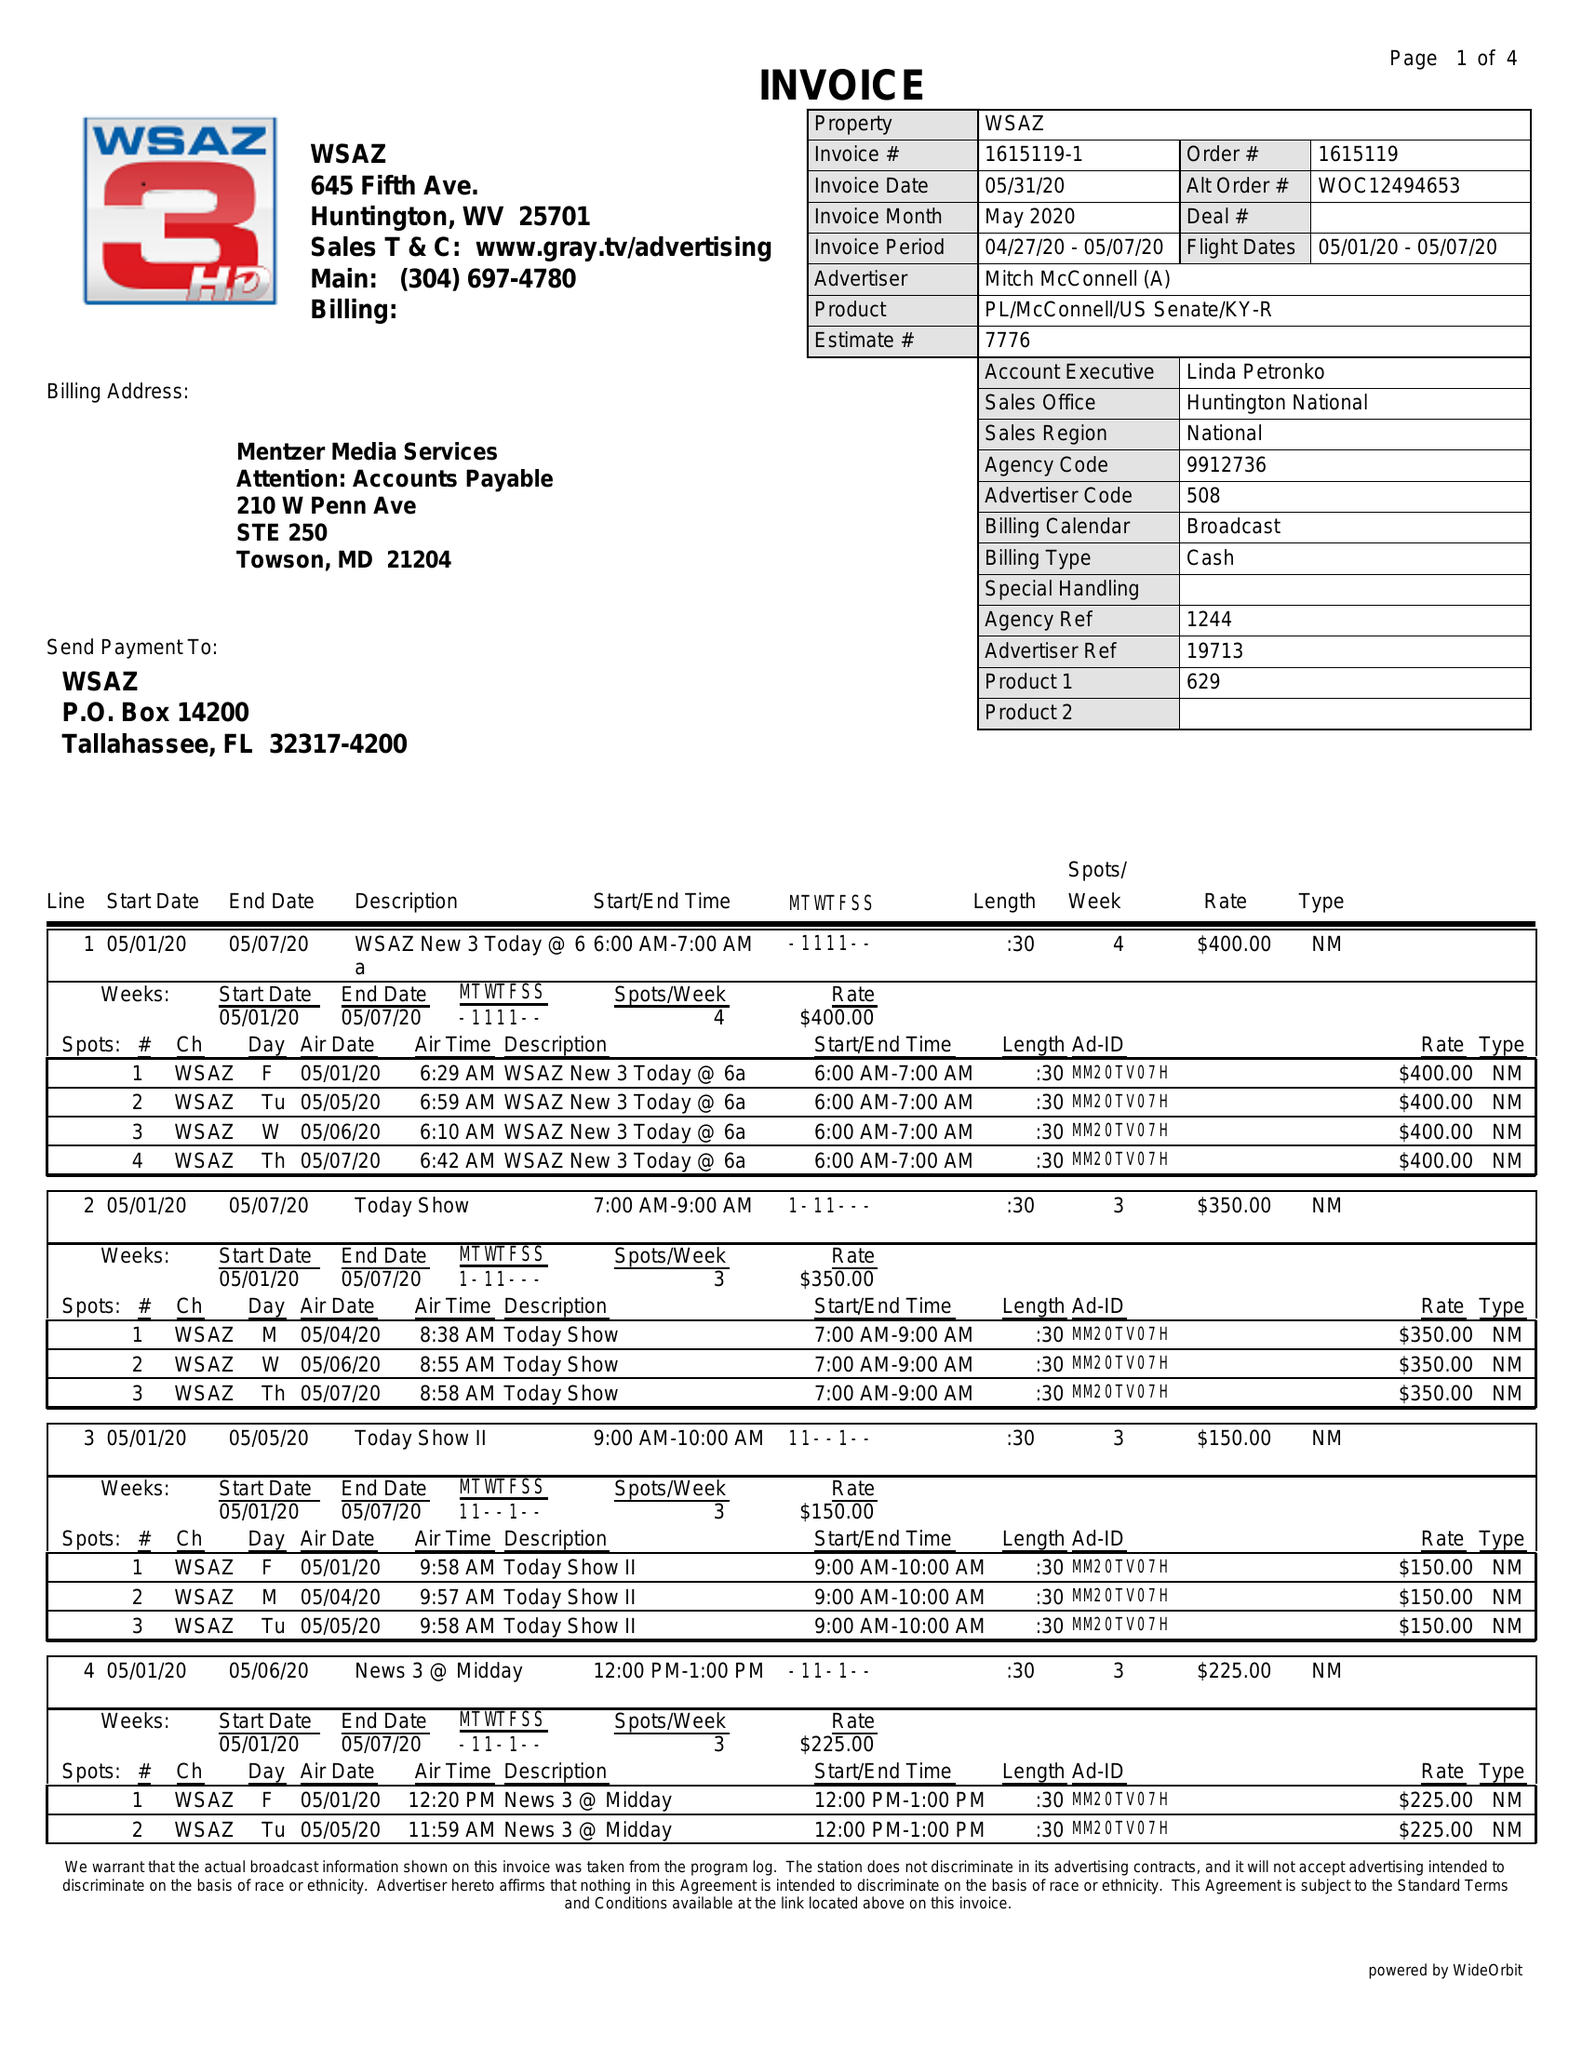What is the value for the advertiser?
Answer the question using a single word or phrase. MITCH MCCONNELL (A) 